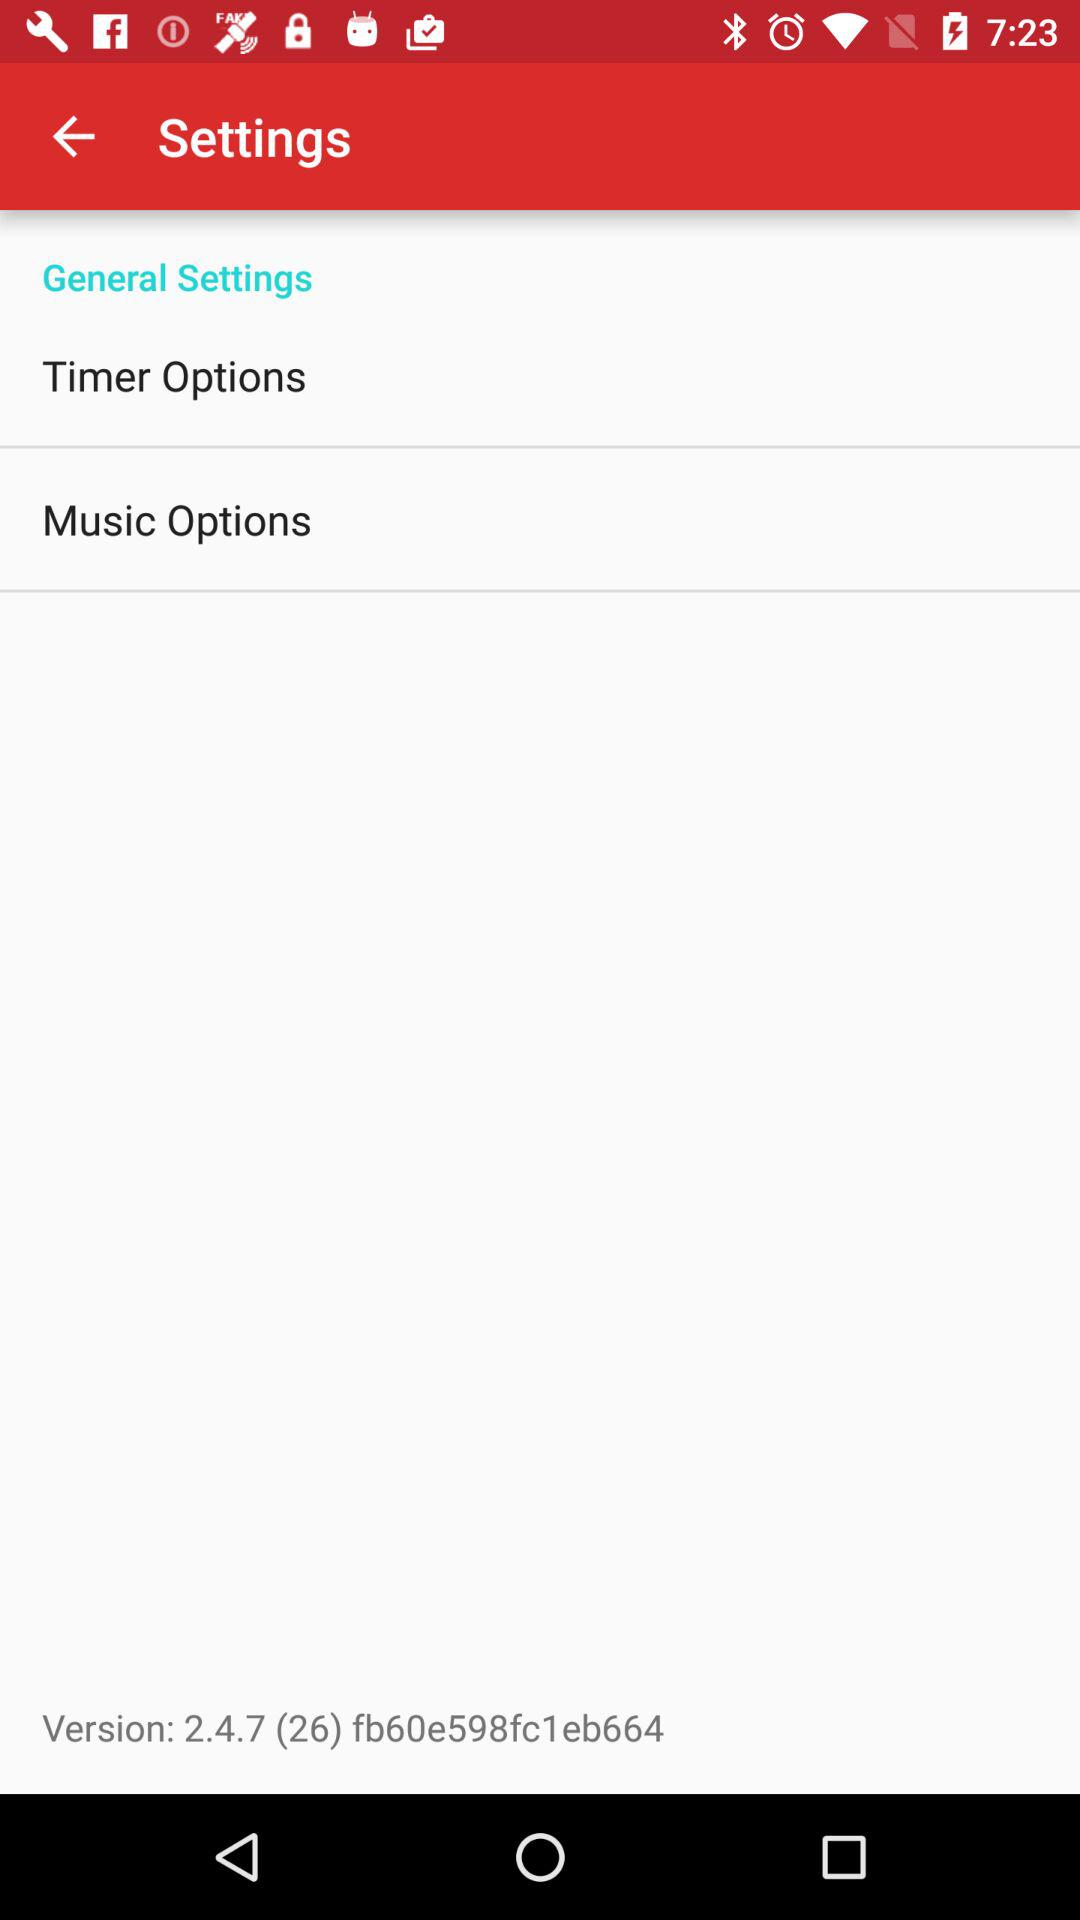What is the version of the application? The version is 2.4.7 (26) fb60e598fc1eb664. 